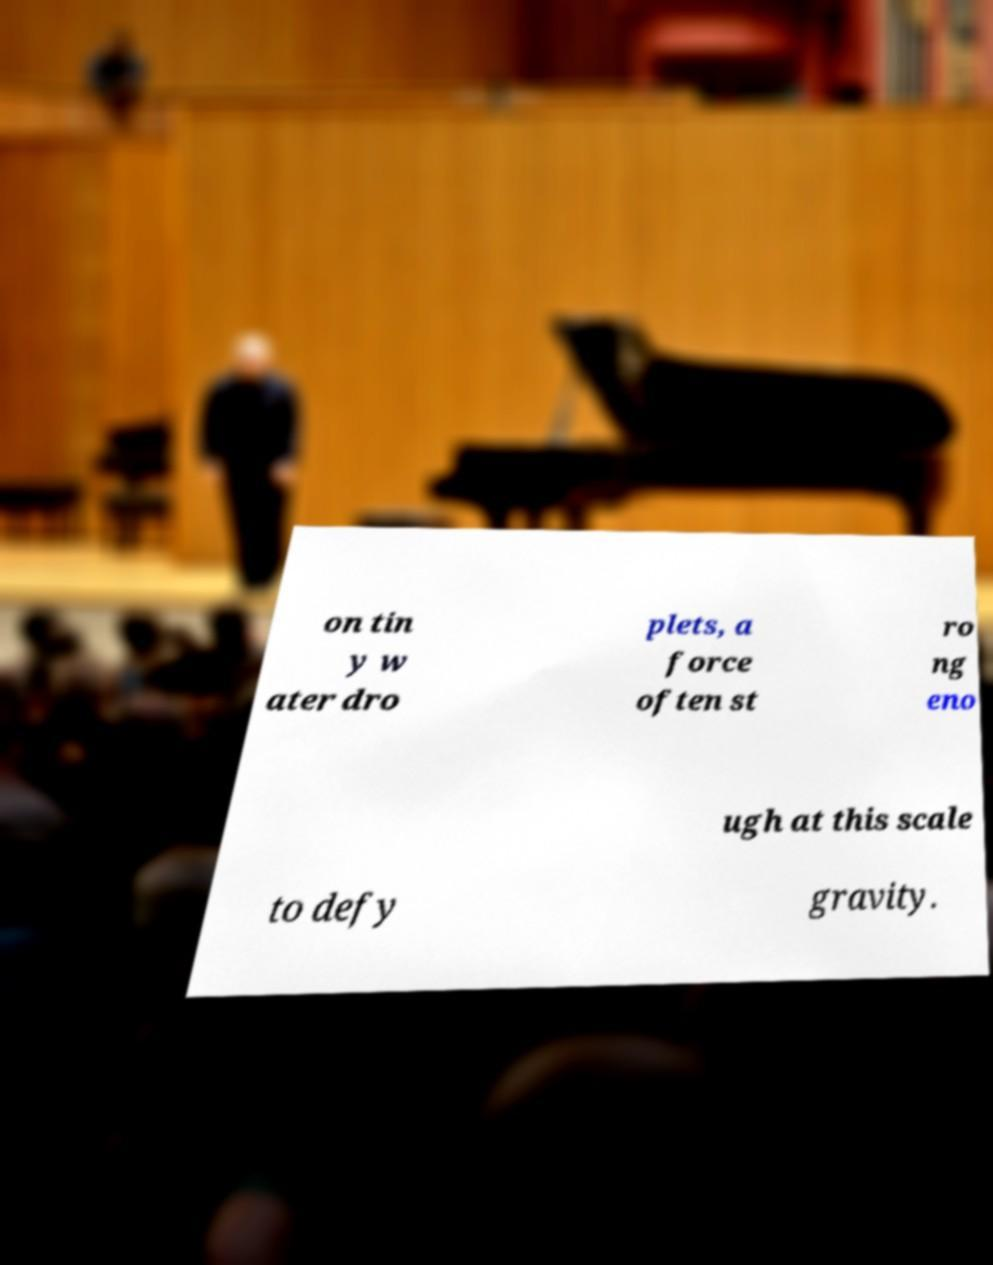Can you read and provide the text displayed in the image?This photo seems to have some interesting text. Can you extract and type it out for me? on tin y w ater dro plets, a force often st ro ng eno ugh at this scale to defy gravity. 